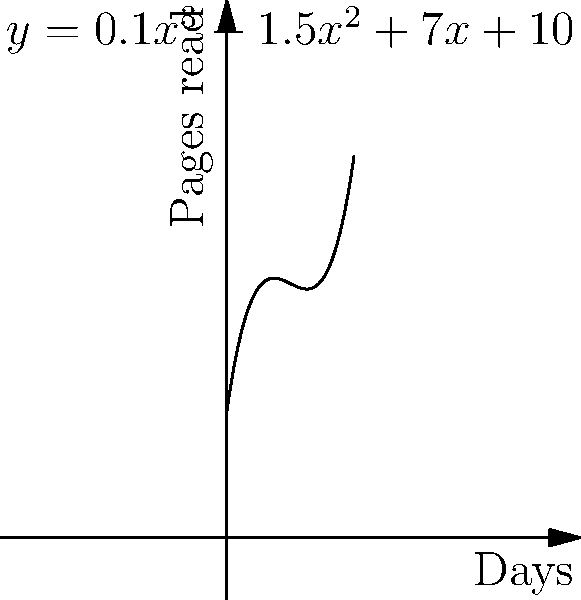A book club has initiated a 10-day relaxation reading program. The number of pages read each day follows the polynomial function $y = 0.1x^3 - 1.5x^2 + 7x + 10$, where $x$ represents the day number and $y$ represents the number of pages read. Calculate the total number of pages read over the entire 10-day program by finding the area under the curve. To find the total number of pages read over the 10-day program, we need to calculate the definite integral of the given function from day 0 to day 10.

1) The function is $f(x) = 0.1x^3 - 1.5x^2 + 7x + 10$

2) We need to integrate this function from 0 to 10:
   $$\int_0^{10} (0.1x^3 - 1.5x^2 + 7x + 10) dx$$

3) Integrate each term:
   $$\left[\frac{0.1x^4}{4} - \frac{1.5x^3}{3} + \frac{7x^2}{2} + 10x\right]_0^{10}$$

4) Evaluate at the upper and lower bounds:
   $$\left(\frac{0.1(10^4)}{4} - \frac{1.5(10^3)}{3} + \frac{7(10^2)}{2} + 10(10)\right) - \left(\frac{0.1(0^4)}{4} - \frac{1.5(0^3)}{3} + \frac{7(0^2)}{2} + 10(0)\right)$$

5) Simplify:
   $$(250 - 500 + 350 + 100) - (0 - 0 + 0 + 0) = 200$$

Therefore, the total number of pages read over the 10-day program is 200 pages.
Answer: 200 pages 